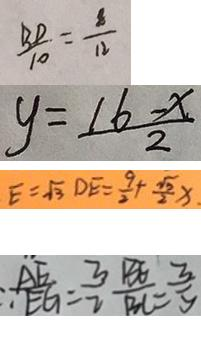<formula> <loc_0><loc_0><loc_500><loc_500>\frac { B D } { 1 0 } = \frac { 8 } { 1 2 } 
 y = \frac { 1 6 - x } { 2 } 
 E = \sqrt { 3 } D E = \frac { 9 } { 2 } + \frac { \sqrt { 3 } } { 2 } x 
 \therefore \frac { A E } { E G } = \frac { 3 } { 2 } \frac { B E } { B C } = \frac { 3 } { 5 }</formula> 